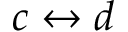<formula> <loc_0><loc_0><loc_500><loc_500>c \leftrightarrow d</formula> 